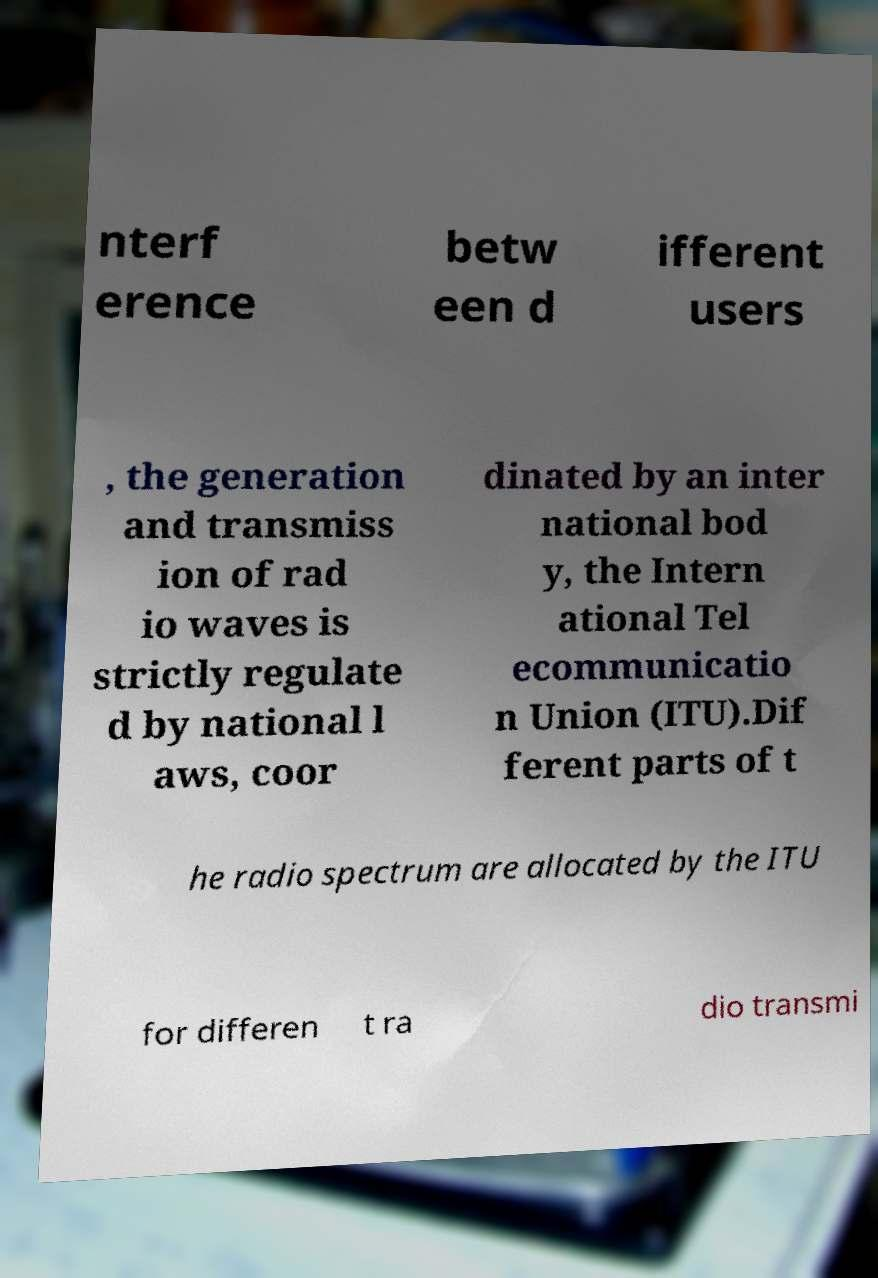For documentation purposes, I need the text within this image transcribed. Could you provide that? nterf erence betw een d ifferent users , the generation and transmiss ion of rad io waves is strictly regulate d by national l aws, coor dinated by an inter national bod y, the Intern ational Tel ecommunicatio n Union (ITU).Dif ferent parts of t he radio spectrum are allocated by the ITU for differen t ra dio transmi 